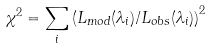<formula> <loc_0><loc_0><loc_500><loc_500>\chi ^ { 2 } = \sum _ { i } \left ( { L _ { m o d } ( \lambda _ { i } ) / L _ { o b s } ( \lambda _ { i } ) } \right ) ^ { 2 }</formula> 